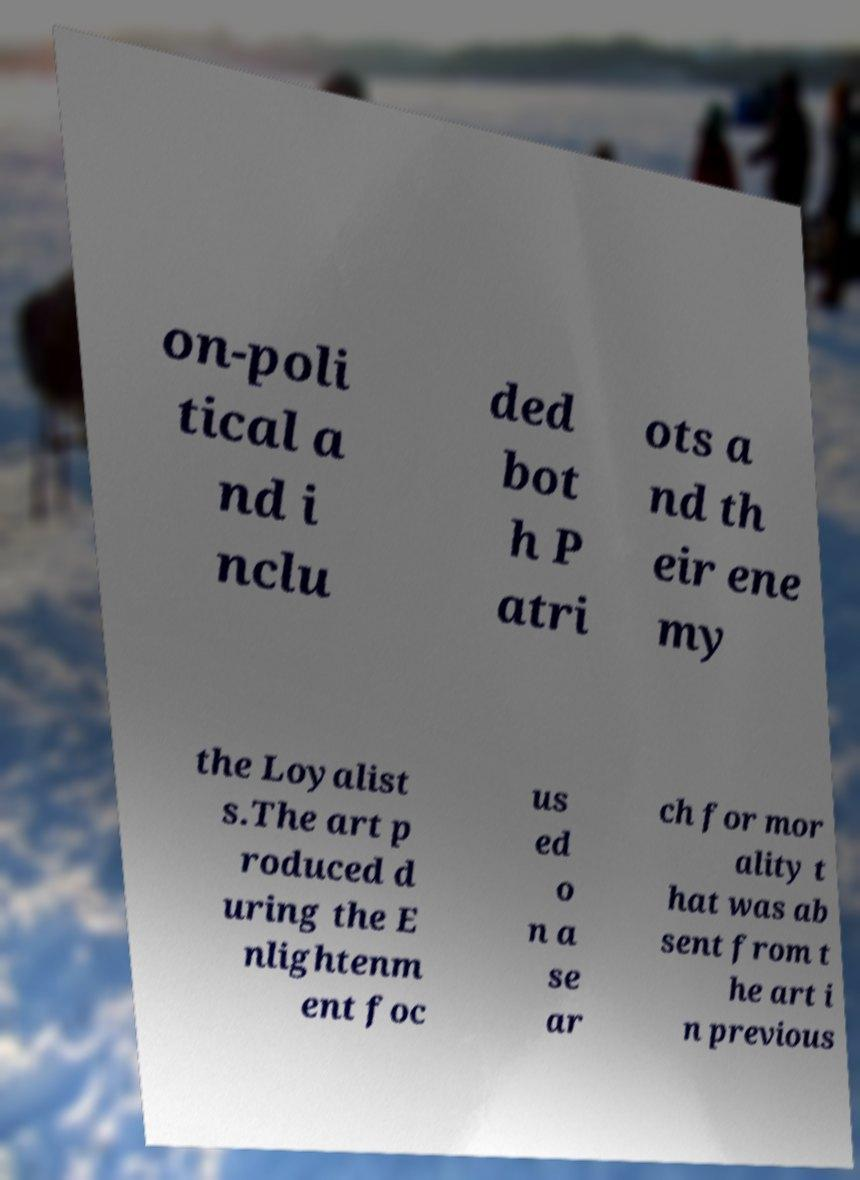For documentation purposes, I need the text within this image transcribed. Could you provide that? on-poli tical a nd i nclu ded bot h P atri ots a nd th eir ene my the Loyalist s.The art p roduced d uring the E nlightenm ent foc us ed o n a se ar ch for mor ality t hat was ab sent from t he art i n previous 